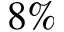Convert formula to latex. <formula><loc_0><loc_0><loc_500><loc_500>8 \%</formula> 